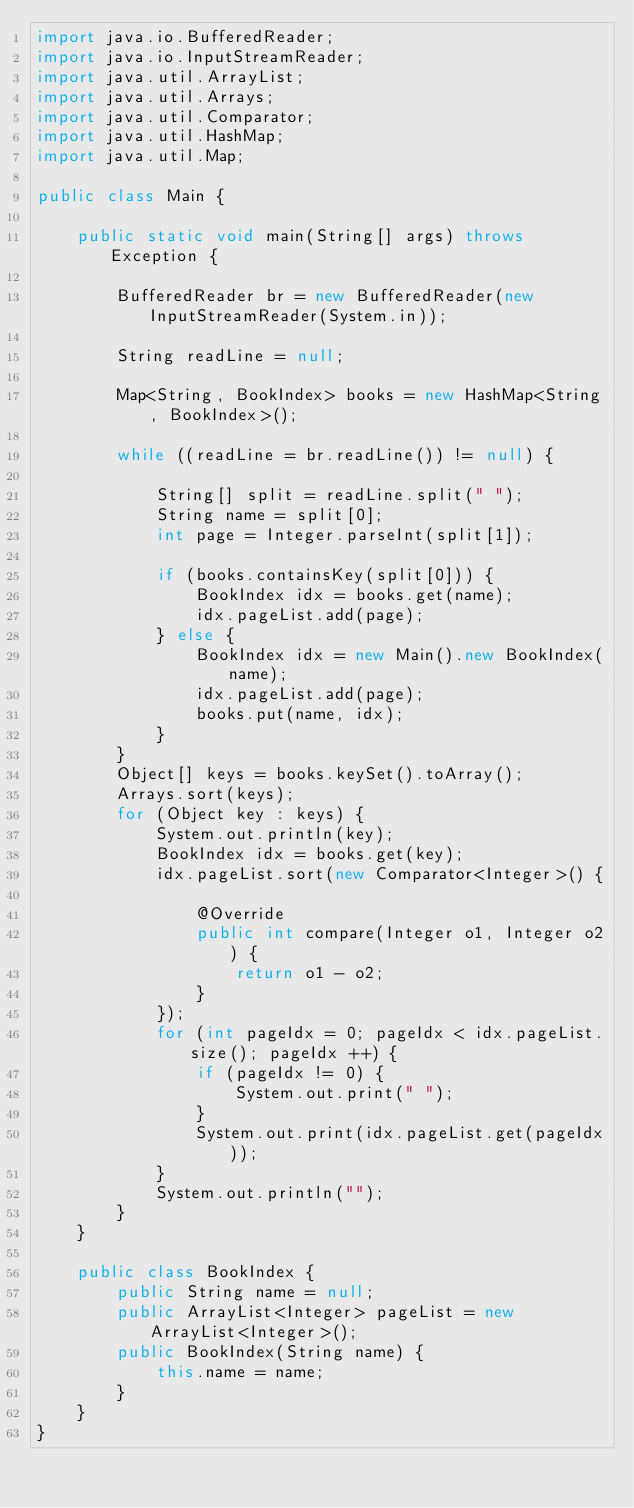<code> <loc_0><loc_0><loc_500><loc_500><_Java_>import java.io.BufferedReader;
import java.io.InputStreamReader;
import java.util.ArrayList;
import java.util.Arrays;
import java.util.Comparator;
import java.util.HashMap;
import java.util.Map;

public class Main {

	public static void main(String[] args) throws Exception {

		BufferedReader br = new BufferedReader(new InputStreamReader(System.in));

		String readLine = null;

		Map<String, BookIndex> books = new HashMap<String, BookIndex>();

		while ((readLine = br.readLine()) != null) {

			String[] split = readLine.split(" ");
			String name = split[0];
			int page = Integer.parseInt(split[1]);

			if (books.containsKey(split[0])) {
				BookIndex idx = books.get(name);
				idx.pageList.add(page);
			} else {
				BookIndex idx = new Main().new BookIndex(name);
				idx.pageList.add(page);
				books.put(name, idx);
			}
		}
		Object[] keys = books.keySet().toArray();
		Arrays.sort(keys);
		for (Object key : keys) {
			System.out.println(key);
			BookIndex idx = books.get(key);
			idx.pageList.sort(new Comparator<Integer>() {

				@Override
				public int compare(Integer o1, Integer o2) {
					return o1 - o2;
				}
			});
			for (int pageIdx = 0; pageIdx < idx.pageList.size(); pageIdx ++) {
				if (pageIdx != 0) {
					System.out.print(" ");
				}
				System.out.print(idx.pageList.get(pageIdx));
			}
			System.out.println("");
		}
	}

	public class BookIndex {
		public String name = null;
		public ArrayList<Integer> pageList = new ArrayList<Integer>();
		public BookIndex(String name) {
			this.name = name;
		}
	}
}</code> 